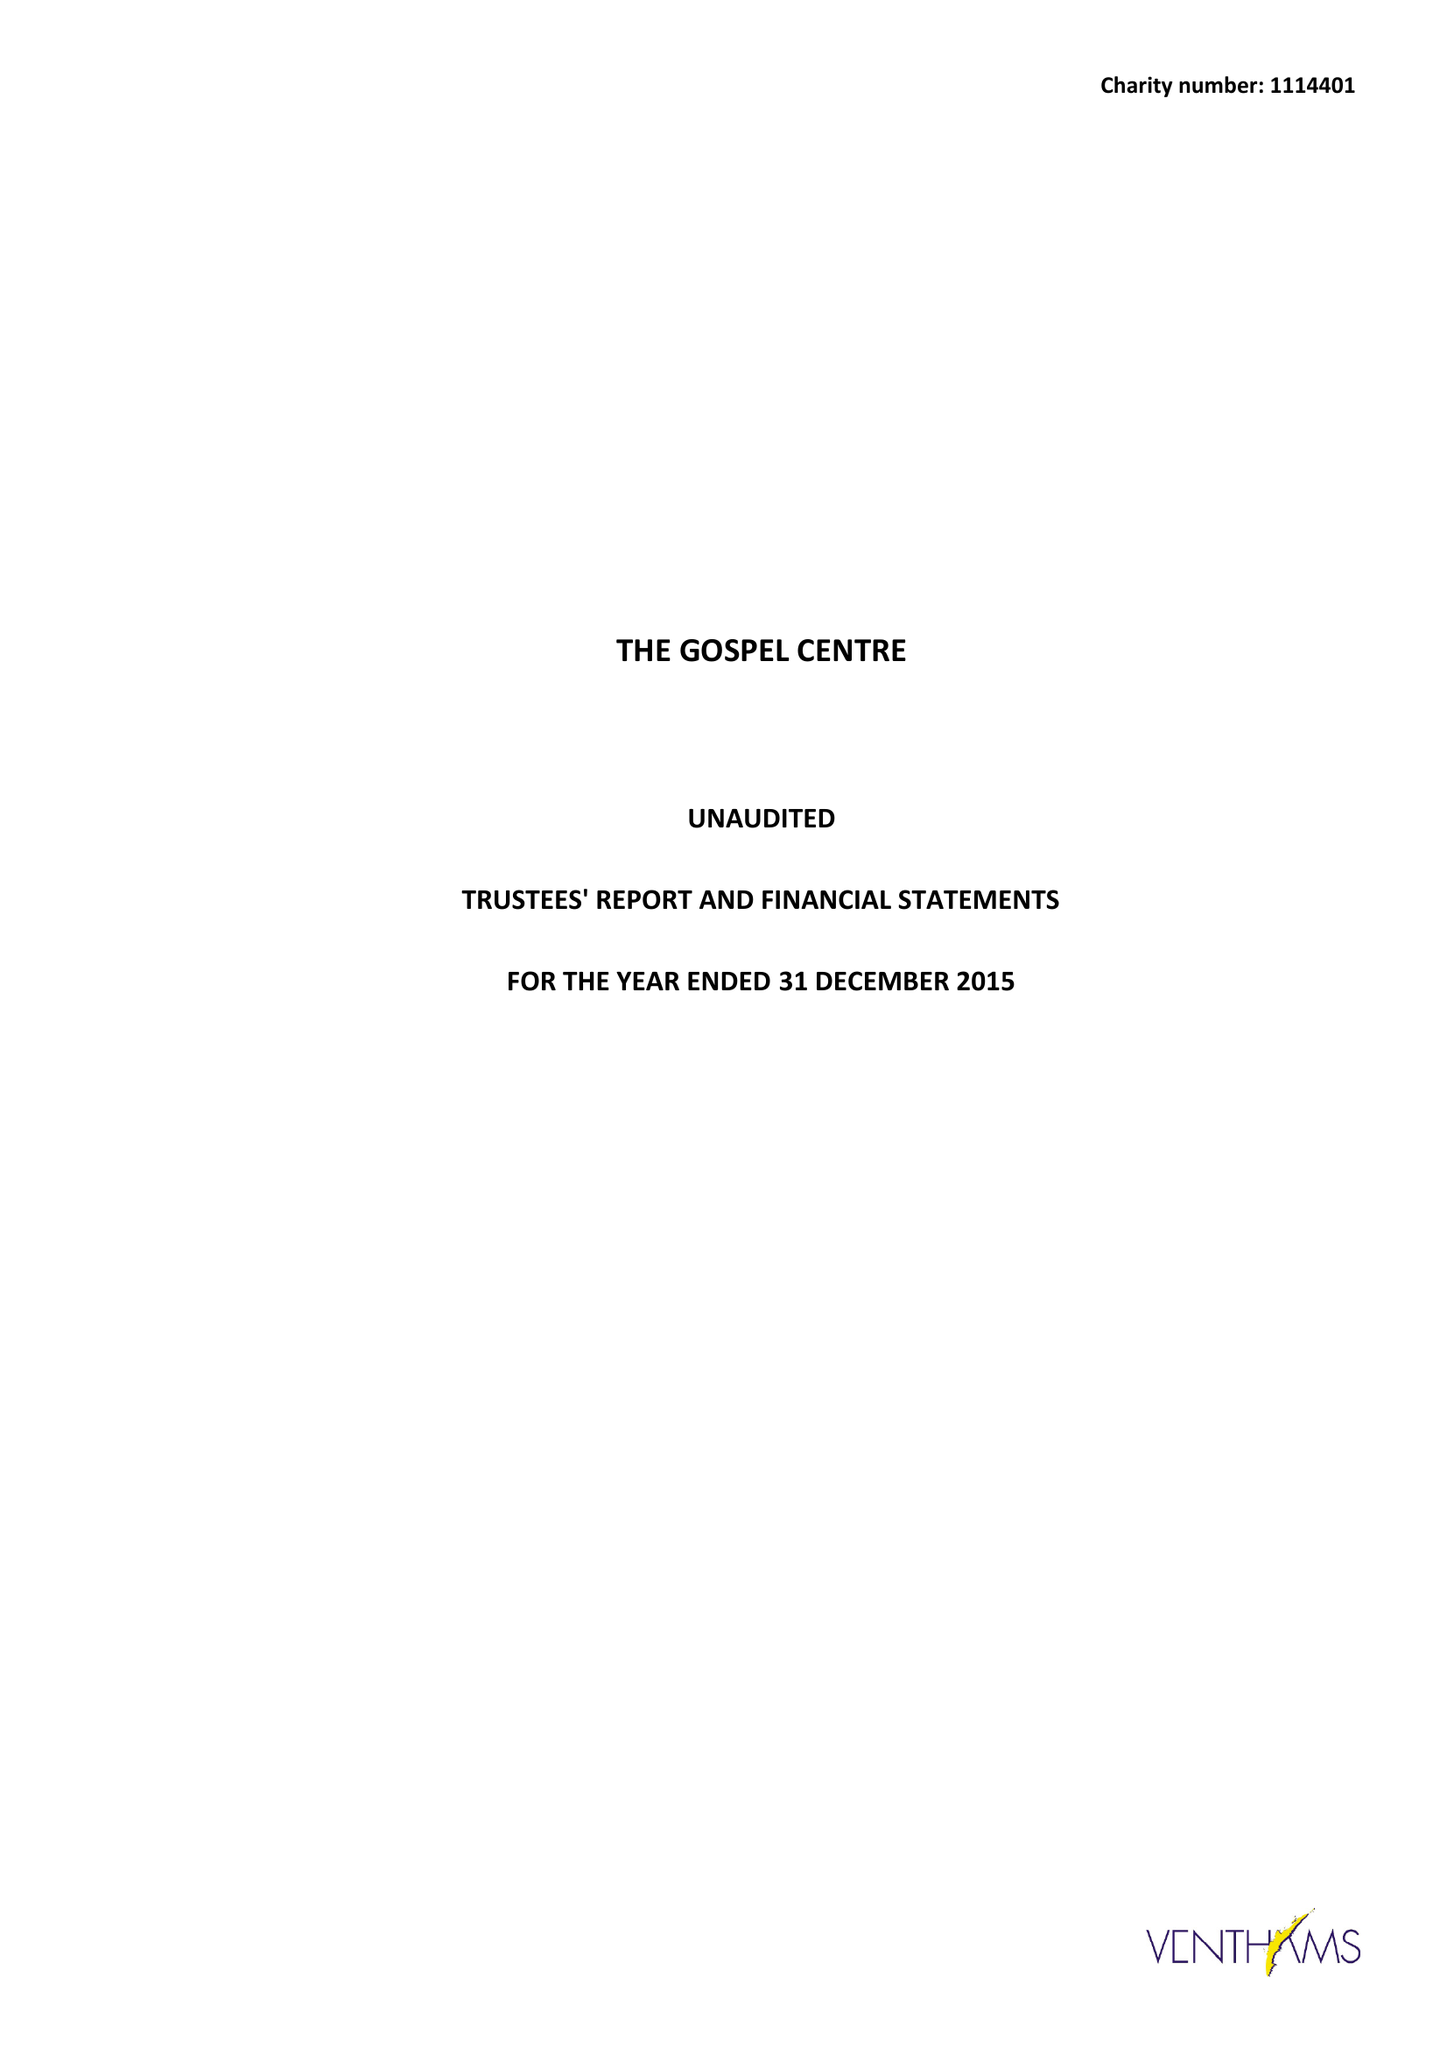What is the value for the charity_name?
Answer the question using a single word or phrase. The Gospel Centre 